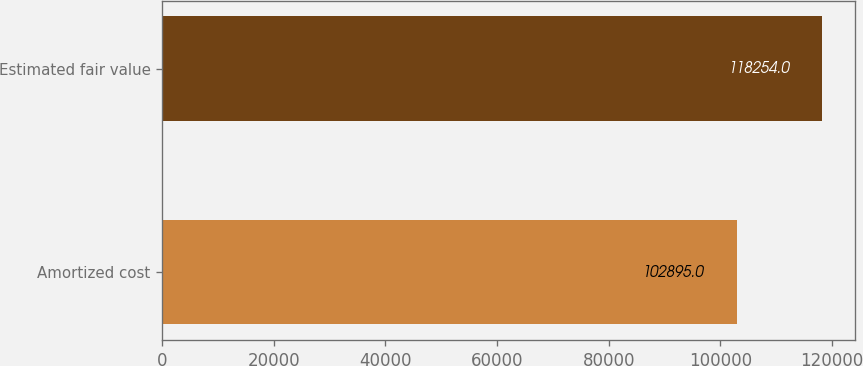Convert chart to OTSL. <chart><loc_0><loc_0><loc_500><loc_500><bar_chart><fcel>Amortized cost<fcel>Estimated fair value<nl><fcel>102895<fcel>118254<nl></chart> 